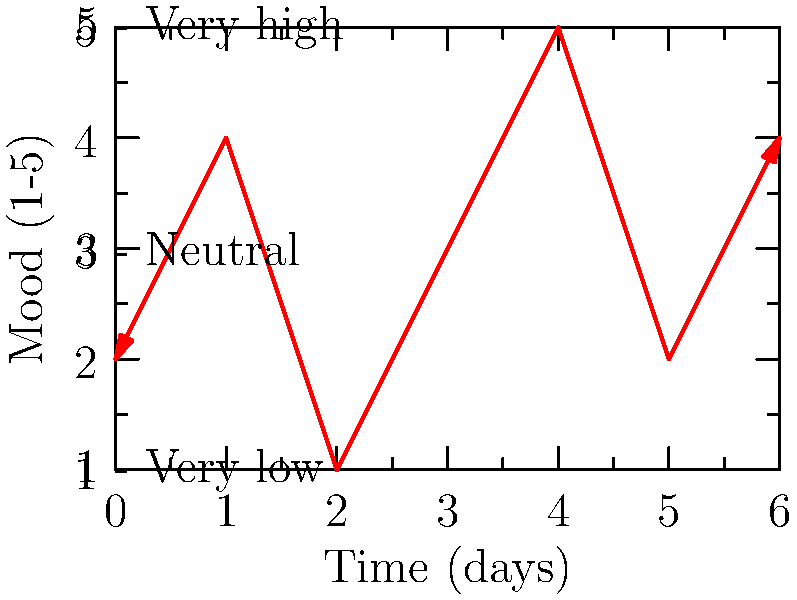Looking at the mood chart above, which shows your emotional states over a week, what topological property best describes the overall pattern of your mood fluctuations? To answer this question, let's analyze the mood chart step-by-step:

1. The chart shows mood levels ranging from 1 (very low) to 5 (very high) over 7 days.

2. We observe that the mood levels change frequently, moving up and down without a consistent trend.

3. The line connecting the mood points does not intersect itself at any point.

4. The changes in mood create a series of "peaks" and "valleys" in the graph.

5. In topology, a continuous line that does not intersect itself and has alternating high and low points is often described as a "zigzag" pattern.

6. This zigzag pattern is topologically equivalent to a sine wave, which is characterized by its oscillating nature.

7. In the context of mood tracking, this oscillating or zigzag pattern suggests frequent mood changes without a stable trend.

Therefore, the topological property that best describes this mood pattern is "oscillation" or "zigzag."
Answer: Oscillation 